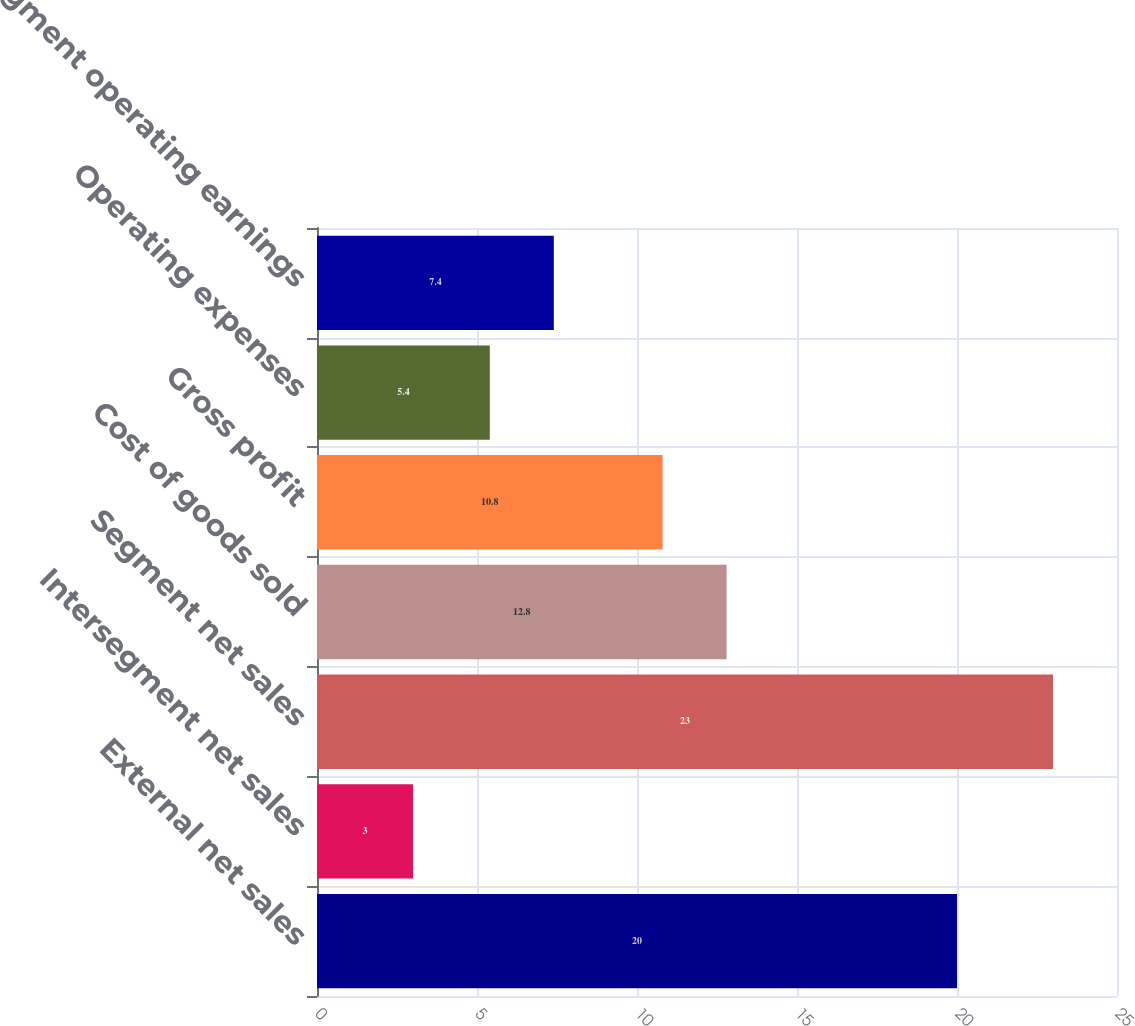<chart> <loc_0><loc_0><loc_500><loc_500><bar_chart><fcel>External net sales<fcel>Intersegment net sales<fcel>Segment net sales<fcel>Cost of goods sold<fcel>Gross profit<fcel>Operating expenses<fcel>Segment operating earnings<nl><fcel>20<fcel>3<fcel>23<fcel>12.8<fcel>10.8<fcel>5.4<fcel>7.4<nl></chart> 